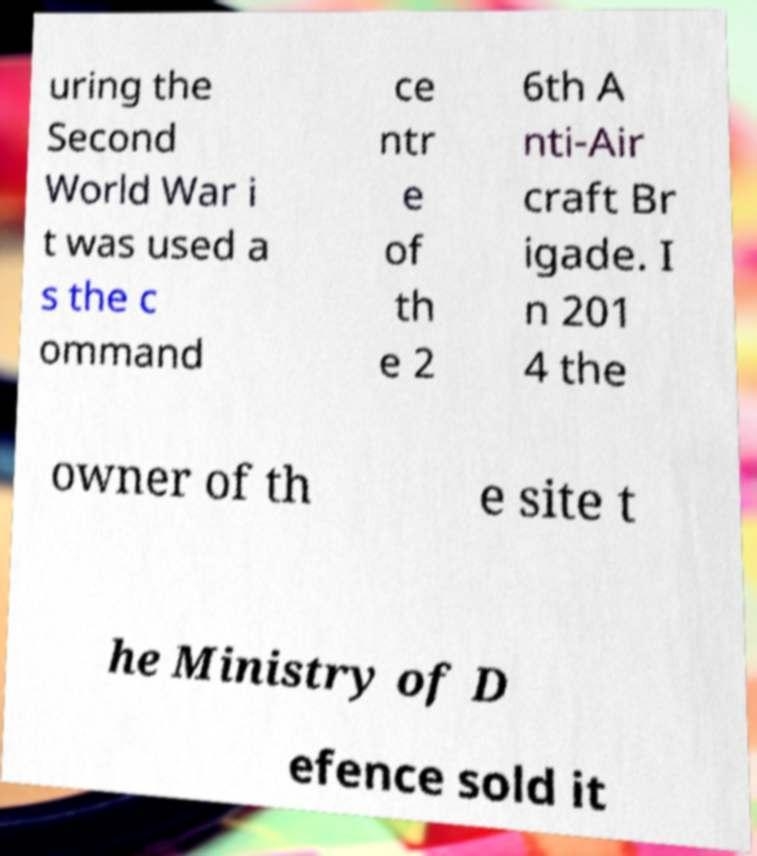Please identify and transcribe the text found in this image. uring the Second World War i t was used a s the c ommand ce ntr e of th e 2 6th A nti-Air craft Br igade. I n 201 4 the owner of th e site t he Ministry of D efence sold it 